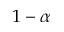Convert formula to latex. <formula><loc_0><loc_0><loc_500><loc_500>1 - \alpha</formula> 